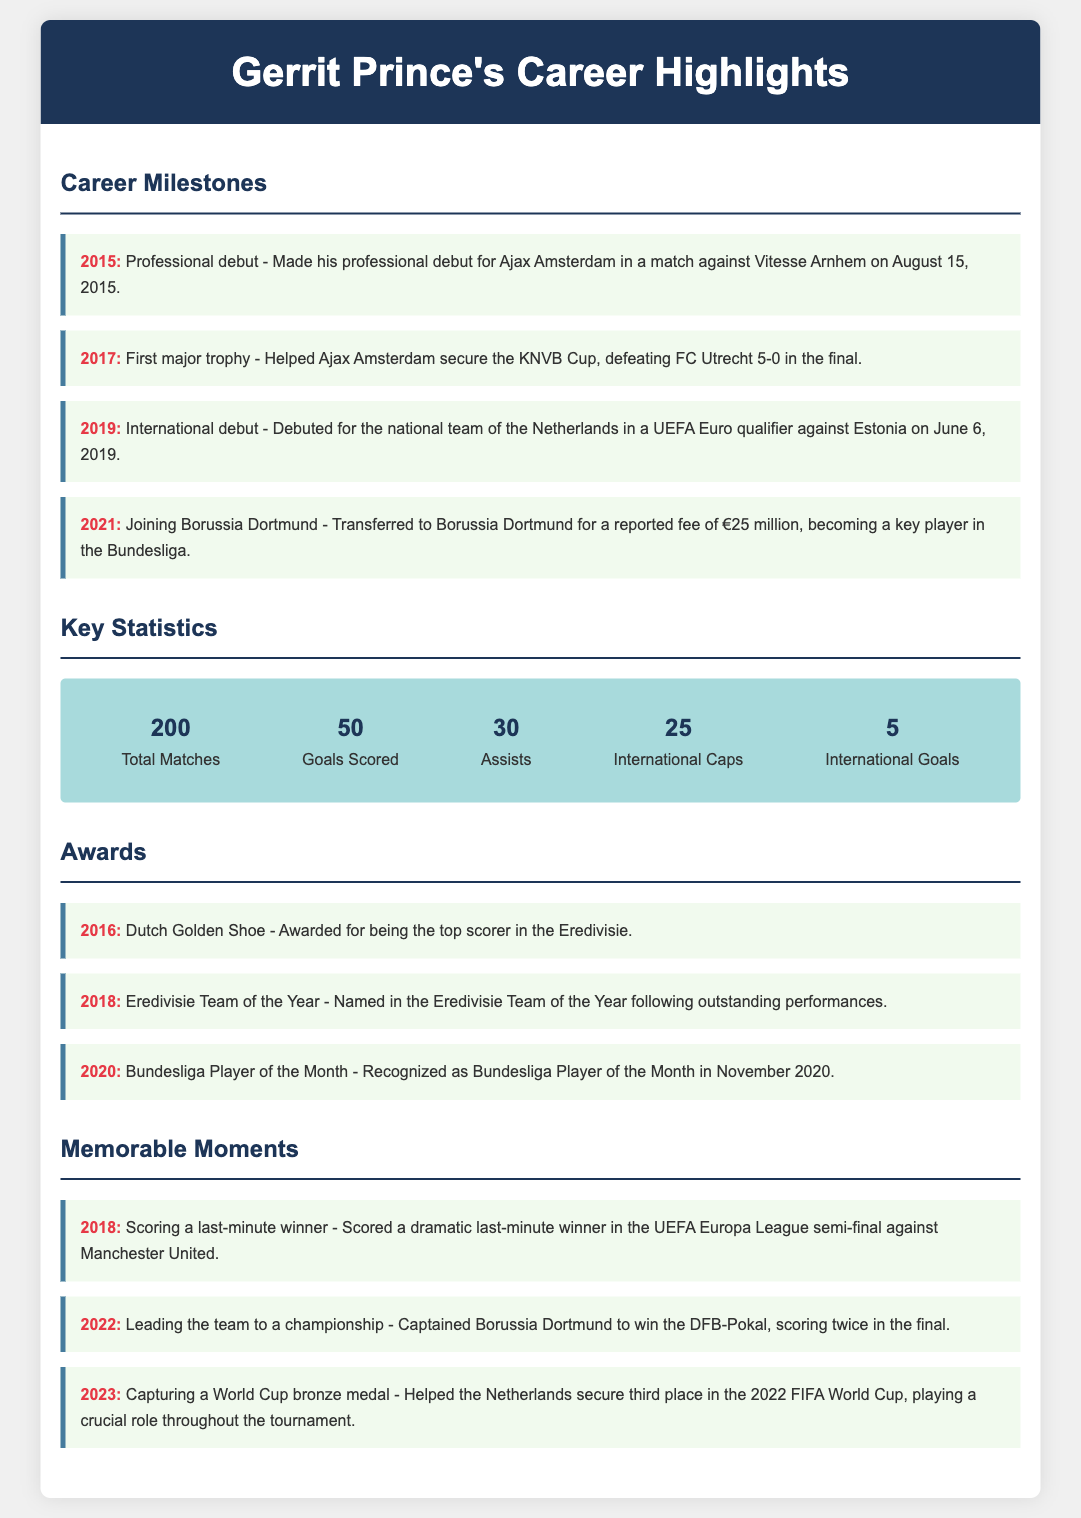what year did Gerrit Prince make his professional debut? The document states he made his professional debut for Ajax Amsterdam in 2015.
Answer: 2015 how many goals has Gerrit Prince scored? According to the key statistics section, he has scored a total of 50 goals.
Answer: 50 which team did Gerrit Prince help secure the KNVB Cup? The document mentions that he helped Ajax Amsterdam secure the KNVB Cup.
Answer: Ajax Amsterdam what major transfer did Gerrit Prince make in 2021? The document notes that he transferred to Borussia Dortmund for a reported fee of €25 million in 2021.
Answer: Borussia Dortmund how many international caps does Gerrit Prince have? The document lists that he has 25 international caps for the national team.
Answer: 25 what award did Gerrit Prince receive in 2016? The document states he was awarded the Dutch Golden Shoe in 2016.
Answer: Dutch Golden Shoe what significant moment occurred in 2018 involving Gerrit Prince? According to the document, he scored a last-minute winner in the UEFA Europa League semi-final in 2018.
Answer: Last-minute winner how many assists does Gerrit Prince have? The key statistics indicate he has provided a total of 30 assists.
Answer: 30 what was Gerrit Prince's achievement in the 2022 FIFA World Cup? The document explains that he helped the Netherlands secure a World Cup bronze medal.
Answer: World Cup bronze medal 